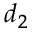<formula> <loc_0><loc_0><loc_500><loc_500>d _ { 2 }</formula> 